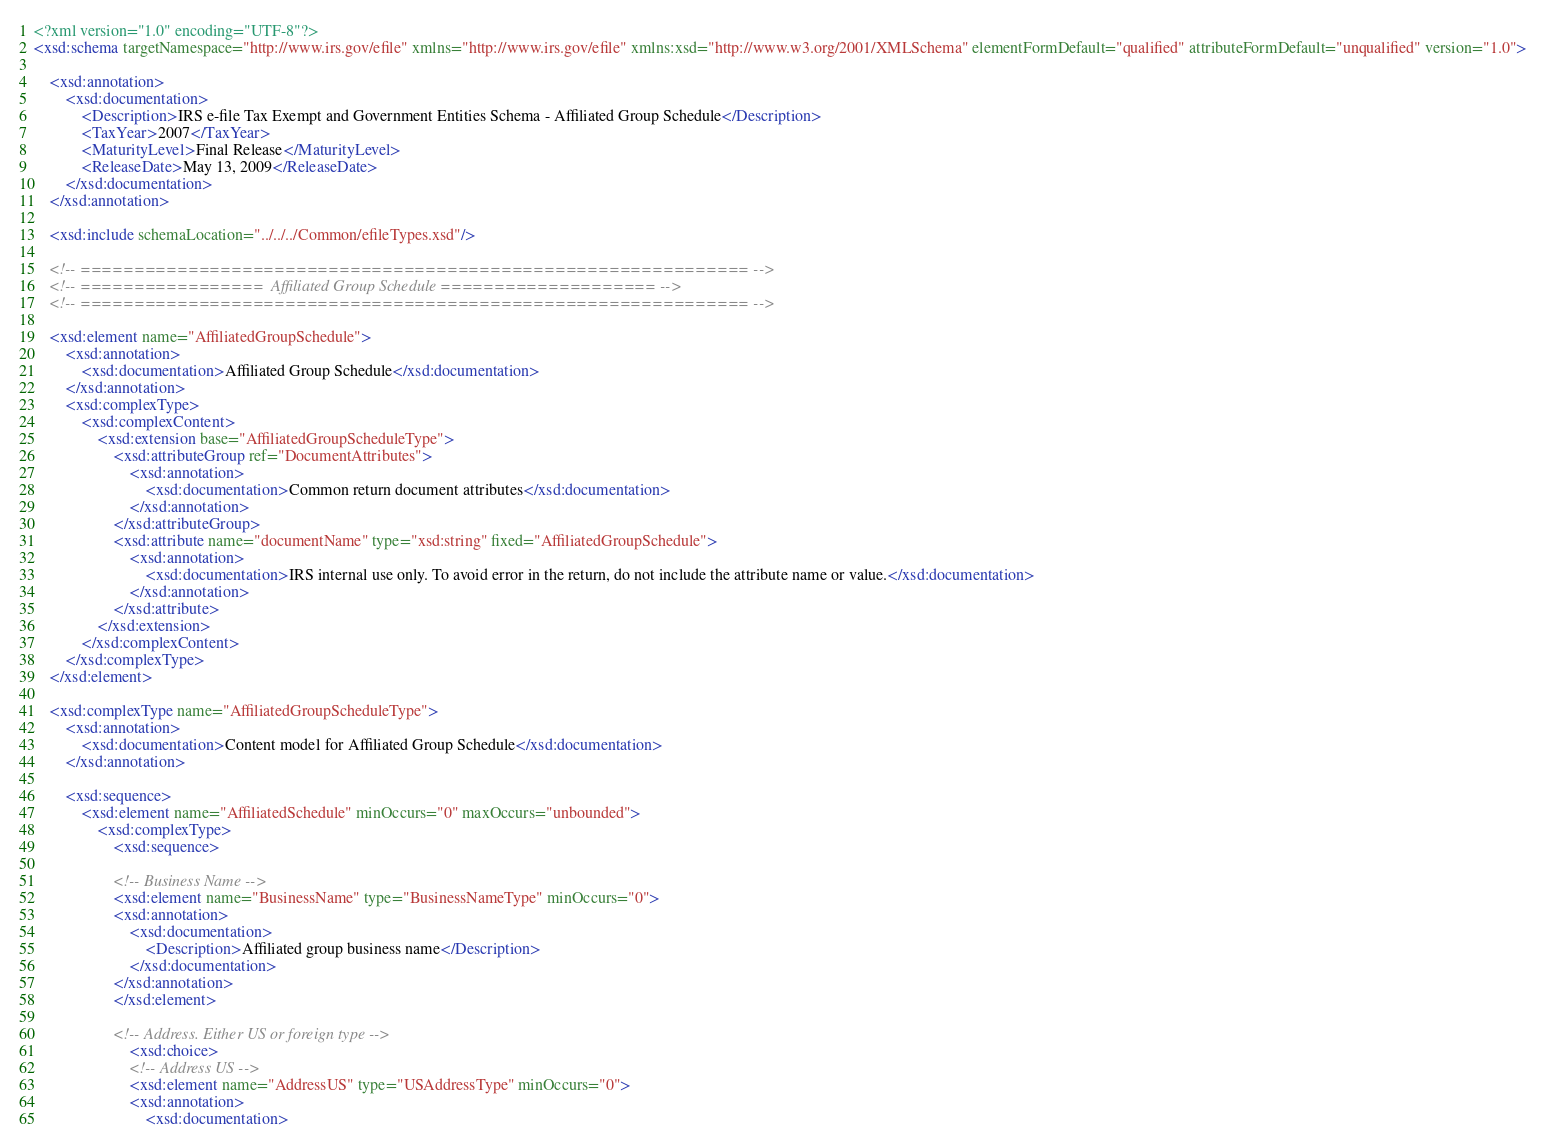<code> <loc_0><loc_0><loc_500><loc_500><_XML_><?xml version="1.0" encoding="UTF-8"?>
<xsd:schema targetNamespace="http://www.irs.gov/efile" xmlns="http://www.irs.gov/efile" xmlns:xsd="http://www.w3.org/2001/XMLSchema" elementFormDefault="qualified" attributeFormDefault="unqualified" version="1.0">

	<xsd:annotation>
		<xsd:documentation>
			<Description>IRS e-file Tax Exempt and Government Entities Schema - Affiliated Group Schedule</Description>
			<TaxYear>2007</TaxYear>
			<MaturityLevel>Final Release</MaturityLevel>
			<ReleaseDate>May 13, 2009</ReleaseDate>
		</xsd:documentation>
	</xsd:annotation>

	<xsd:include schemaLocation="../../../Common/efileTypes.xsd"/>

	<!-- ============================================================== -->
	<!-- =================  Affiliated Group Schedule ==================== -->
	<!-- ============================================================== -->

	<xsd:element name="AffiliatedGroupSchedule">
		<xsd:annotation>
			<xsd:documentation>Affiliated Group Schedule</xsd:documentation>
		</xsd:annotation>
		<xsd:complexType>
			<xsd:complexContent>
				<xsd:extension base="AffiliatedGroupScheduleType">
					<xsd:attributeGroup ref="DocumentAttributes">
						<xsd:annotation>
							<xsd:documentation>Common return document attributes</xsd:documentation>
						</xsd:annotation>
					</xsd:attributeGroup>
					<xsd:attribute name="documentName" type="xsd:string" fixed="AffiliatedGroupSchedule">
						<xsd:annotation>
							<xsd:documentation>IRS internal use only. To avoid error in the return, do not include the attribute name or value.</xsd:documentation>
						</xsd:annotation>
					</xsd:attribute>
				</xsd:extension>
			</xsd:complexContent>
		</xsd:complexType>
	</xsd:element>
	
	<xsd:complexType name="AffiliatedGroupScheduleType">
		<xsd:annotation>
			<xsd:documentation>Content model for Affiliated Group Schedule</xsd:documentation>
		</xsd:annotation>
		
		<xsd:sequence>
			<xsd:element name="AffiliatedSchedule" minOccurs="0" maxOccurs="unbounded">
				<xsd:complexType>
					<xsd:sequence>

					<!-- Business Name -->
					<xsd:element name="BusinessName" type="BusinessNameType" minOccurs="0">
					<xsd:annotation>
						<xsd:documentation>
							<Description>Affiliated group business name</Description>
						</xsd:documentation>
					</xsd:annotation>
					</xsd:element>	

					<!-- Address. Either US or foreign type -->
		      			<xsd:choice>
						<!-- Address US -->
						<xsd:element name="AddressUS" type="USAddressType" minOccurs="0">
						<xsd:annotation>
							<xsd:documentation></code> 